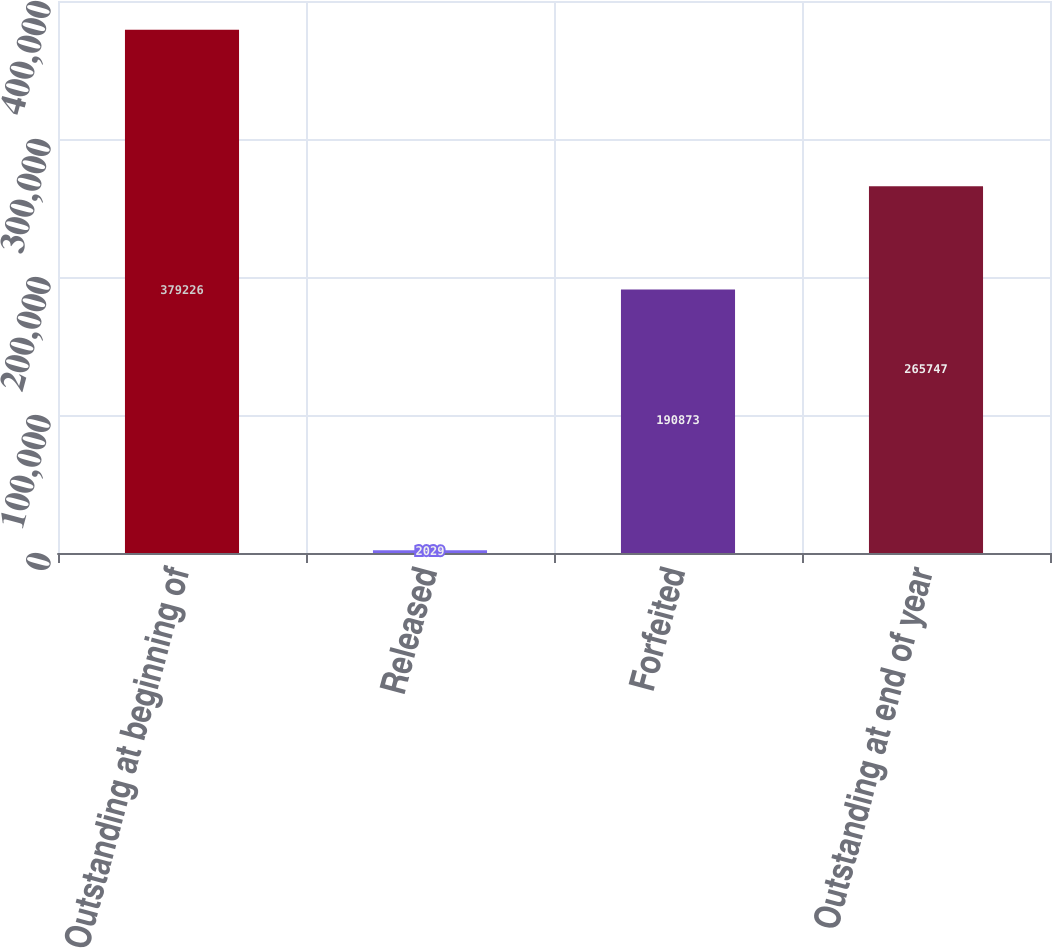<chart> <loc_0><loc_0><loc_500><loc_500><bar_chart><fcel>Outstanding at beginning of<fcel>Released<fcel>Forfeited<fcel>Outstanding at end of year<nl><fcel>379226<fcel>2029<fcel>190873<fcel>265747<nl></chart> 